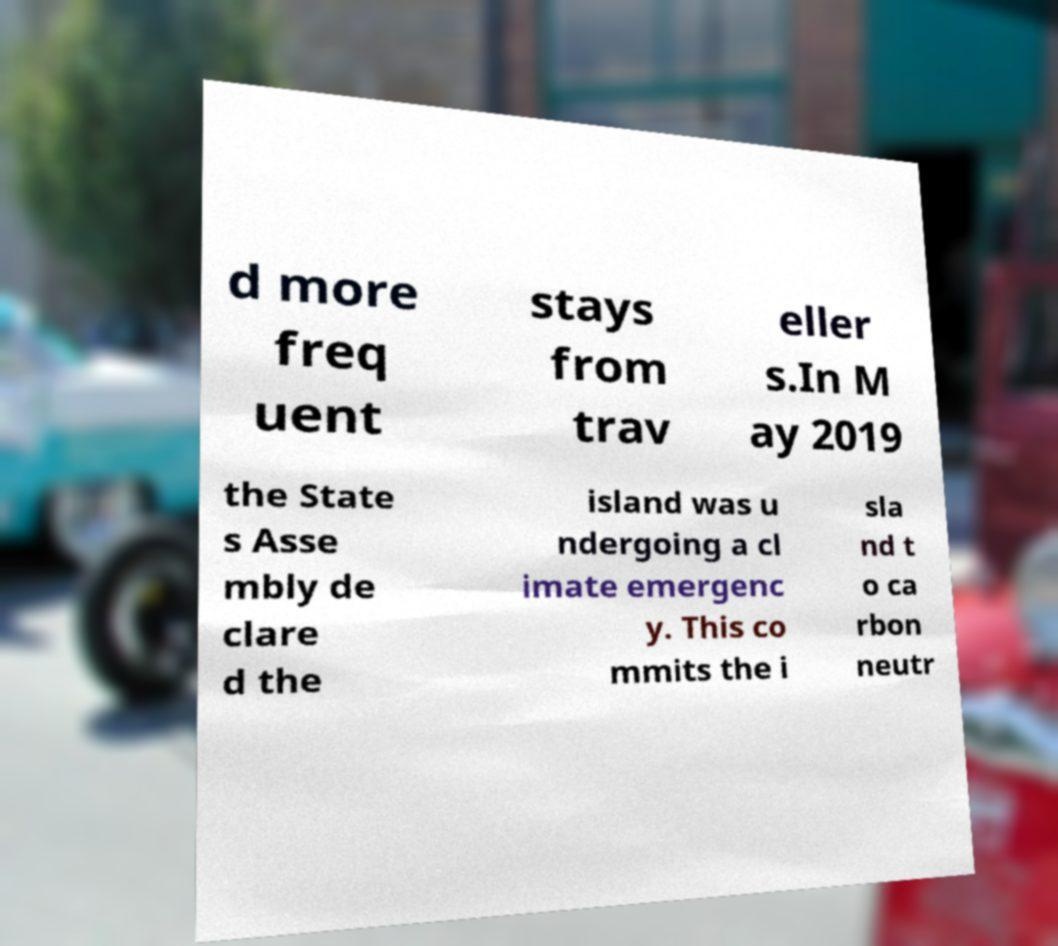Could you assist in decoding the text presented in this image and type it out clearly? d more freq uent stays from trav eller s.In M ay 2019 the State s Asse mbly de clare d the island was u ndergoing a cl imate emergenc y. This co mmits the i sla nd t o ca rbon neutr 